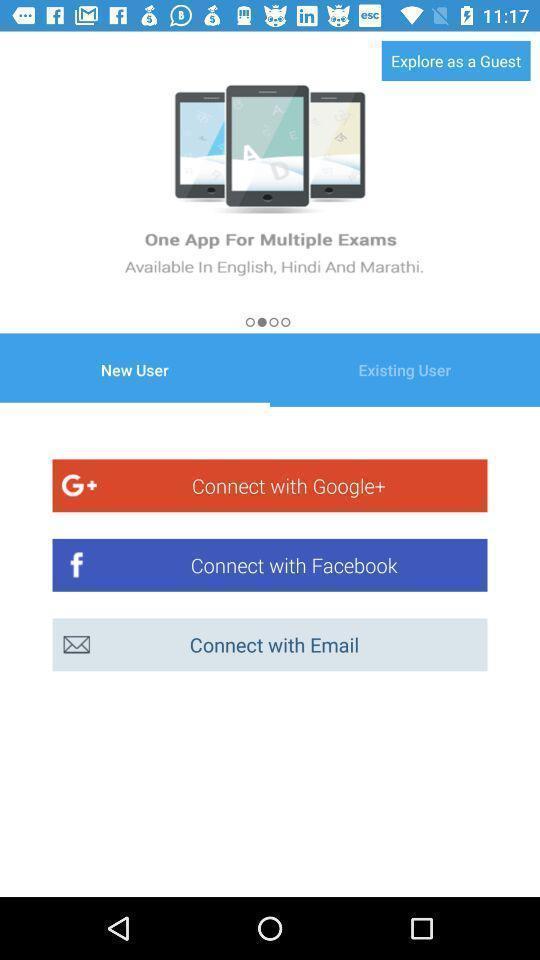Describe the visual elements of this screenshot. Welcome page for logging into account. 